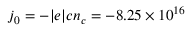<formula> <loc_0><loc_0><loc_500><loc_500>j _ { 0 } = - | e | c n _ { c } = - 8 . 2 5 \times 1 0 ^ { 1 6 }</formula> 